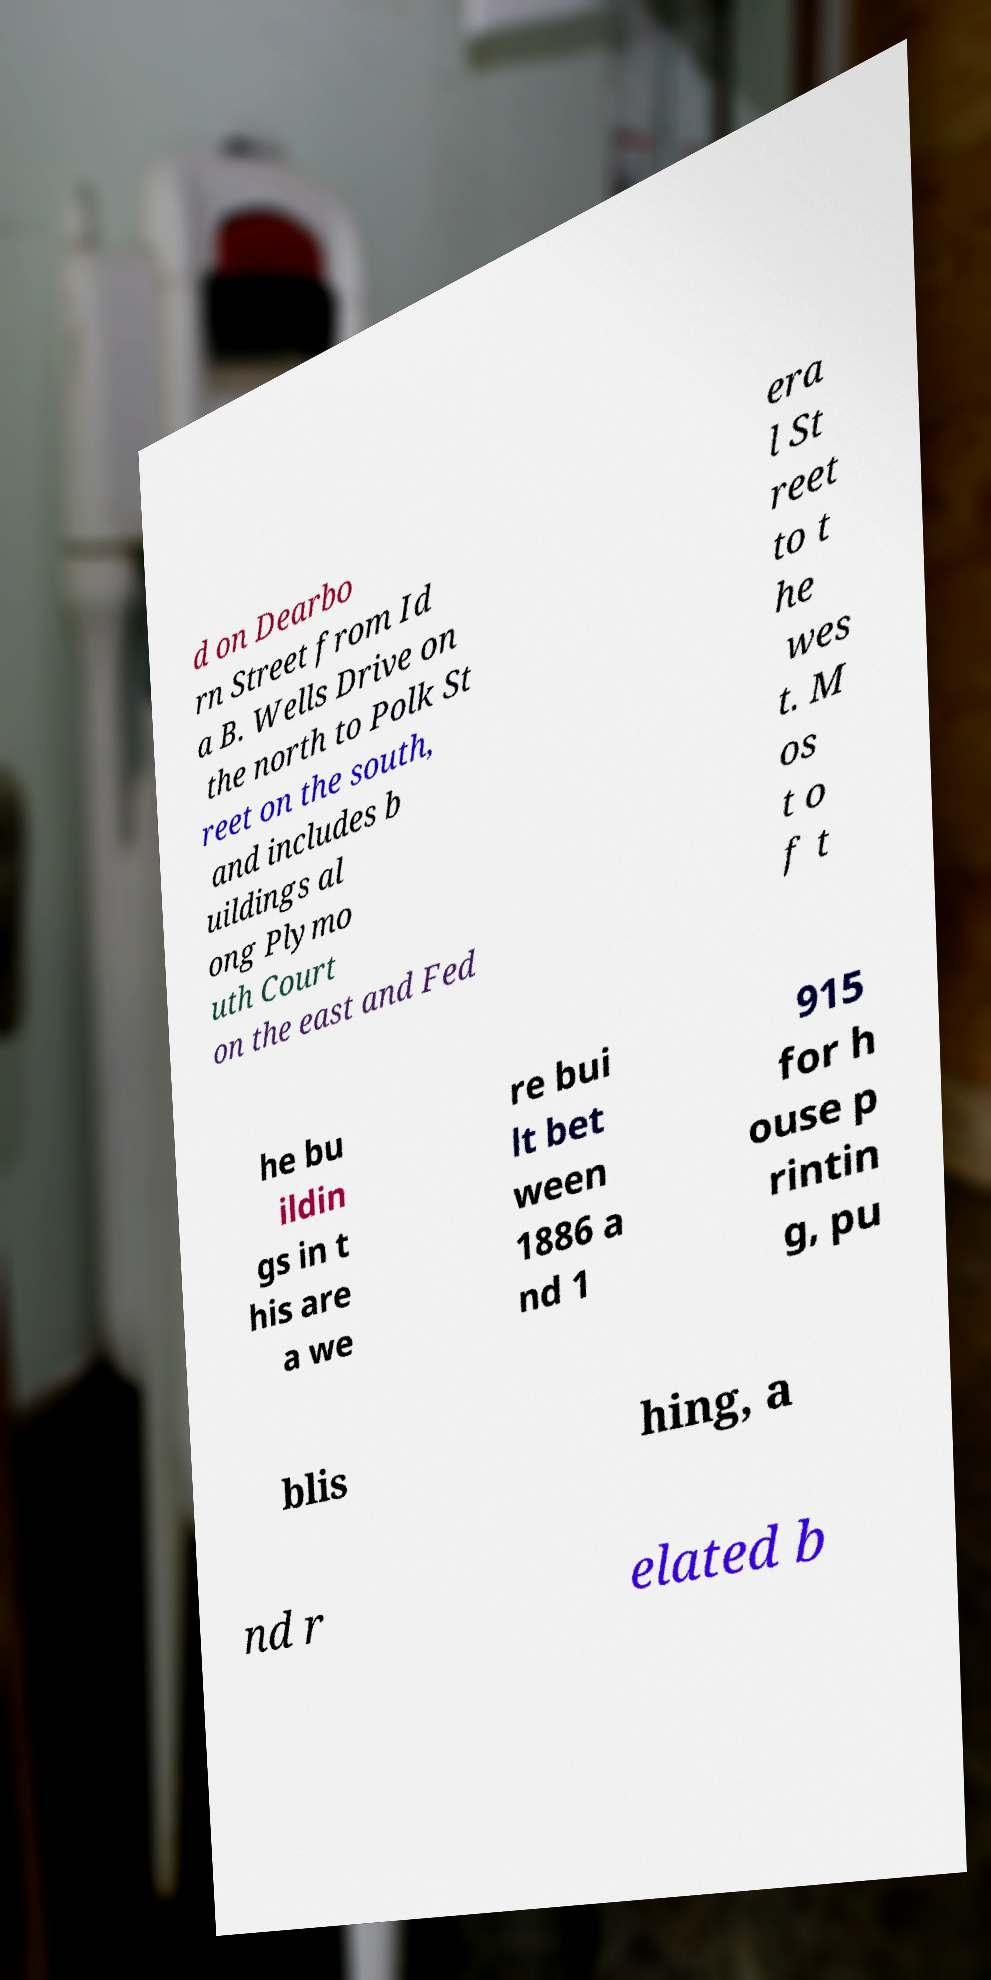Can you accurately transcribe the text from the provided image for me? d on Dearbo rn Street from Id a B. Wells Drive on the north to Polk St reet on the south, and includes b uildings al ong Plymo uth Court on the east and Fed era l St reet to t he wes t. M os t o f t he bu ildin gs in t his are a we re bui lt bet ween 1886 a nd 1 915 for h ouse p rintin g, pu blis hing, a nd r elated b 